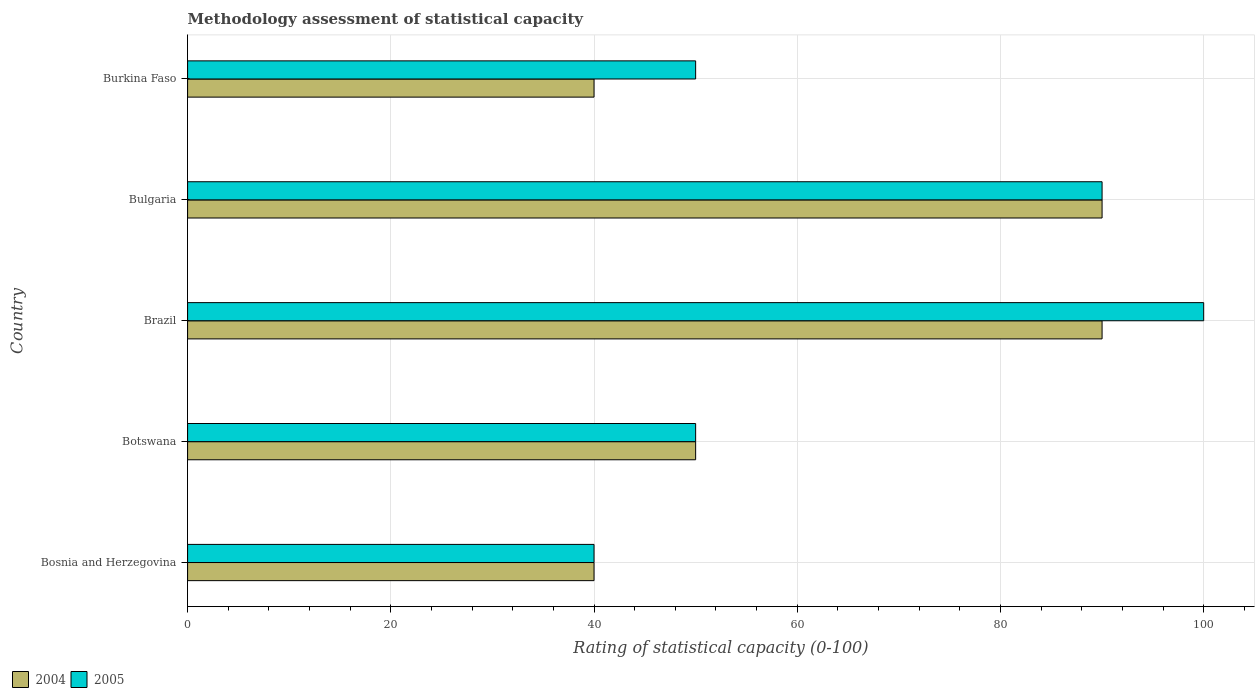How many groups of bars are there?
Offer a terse response. 5. Are the number of bars per tick equal to the number of legend labels?
Provide a succinct answer. Yes. Are the number of bars on each tick of the Y-axis equal?
Ensure brevity in your answer.  Yes. How many bars are there on the 5th tick from the top?
Your answer should be compact. 2. What is the label of the 4th group of bars from the top?
Provide a succinct answer. Botswana. In how many cases, is the number of bars for a given country not equal to the number of legend labels?
Ensure brevity in your answer.  0. Across all countries, what is the minimum rating of statistical capacity in 2005?
Provide a short and direct response. 40. In which country was the rating of statistical capacity in 2005 maximum?
Ensure brevity in your answer.  Brazil. In which country was the rating of statistical capacity in 2005 minimum?
Provide a succinct answer. Bosnia and Herzegovina. What is the total rating of statistical capacity in 2005 in the graph?
Ensure brevity in your answer.  330. What is the difference between the rating of statistical capacity in 2004 in Bosnia and Herzegovina and that in Botswana?
Keep it short and to the point. -10. What is the difference between the rating of statistical capacity in 2005 and rating of statistical capacity in 2004 in Bulgaria?
Offer a very short reply. 0. What is the ratio of the rating of statistical capacity in 2004 in Bulgaria to that in Burkina Faso?
Offer a very short reply. 2.25. Is the rating of statistical capacity in 2005 in Botswana less than that in Brazil?
Provide a succinct answer. Yes. What is the difference between the highest and the second highest rating of statistical capacity in 2004?
Make the answer very short. 0. What is the difference between the highest and the lowest rating of statistical capacity in 2004?
Provide a succinct answer. 50. Is the sum of the rating of statistical capacity in 2004 in Botswana and Bulgaria greater than the maximum rating of statistical capacity in 2005 across all countries?
Provide a short and direct response. Yes. What does the 1st bar from the top in Botswana represents?
Offer a very short reply. 2005. How many bars are there?
Give a very brief answer. 10. Are all the bars in the graph horizontal?
Offer a terse response. Yes. How many countries are there in the graph?
Provide a short and direct response. 5. What is the difference between two consecutive major ticks on the X-axis?
Your response must be concise. 20. Does the graph contain grids?
Give a very brief answer. Yes. Where does the legend appear in the graph?
Ensure brevity in your answer.  Bottom left. How many legend labels are there?
Ensure brevity in your answer.  2. How are the legend labels stacked?
Offer a terse response. Horizontal. What is the title of the graph?
Your answer should be very brief. Methodology assessment of statistical capacity. What is the label or title of the X-axis?
Provide a succinct answer. Rating of statistical capacity (0-100). What is the Rating of statistical capacity (0-100) in 2004 in Bosnia and Herzegovina?
Keep it short and to the point. 40. What is the Rating of statistical capacity (0-100) in 2004 in Bulgaria?
Provide a short and direct response. 90. What is the Rating of statistical capacity (0-100) of 2005 in Bulgaria?
Keep it short and to the point. 90. Across all countries, what is the maximum Rating of statistical capacity (0-100) in 2005?
Ensure brevity in your answer.  100. Across all countries, what is the minimum Rating of statistical capacity (0-100) in 2004?
Your answer should be very brief. 40. What is the total Rating of statistical capacity (0-100) in 2004 in the graph?
Give a very brief answer. 310. What is the total Rating of statistical capacity (0-100) in 2005 in the graph?
Provide a short and direct response. 330. What is the difference between the Rating of statistical capacity (0-100) in 2005 in Bosnia and Herzegovina and that in Brazil?
Provide a short and direct response. -60. What is the difference between the Rating of statistical capacity (0-100) in 2005 in Bosnia and Herzegovina and that in Bulgaria?
Provide a succinct answer. -50. What is the difference between the Rating of statistical capacity (0-100) in 2004 in Bosnia and Herzegovina and that in Burkina Faso?
Keep it short and to the point. 0. What is the difference between the Rating of statistical capacity (0-100) of 2005 in Botswana and that in Burkina Faso?
Your answer should be very brief. 0. What is the difference between the Rating of statistical capacity (0-100) of 2004 in Brazil and that in Bulgaria?
Keep it short and to the point. 0. What is the difference between the Rating of statistical capacity (0-100) of 2005 in Brazil and that in Bulgaria?
Offer a terse response. 10. What is the difference between the Rating of statistical capacity (0-100) of 2005 in Bulgaria and that in Burkina Faso?
Your response must be concise. 40. What is the difference between the Rating of statistical capacity (0-100) of 2004 in Bosnia and Herzegovina and the Rating of statistical capacity (0-100) of 2005 in Botswana?
Your answer should be very brief. -10. What is the difference between the Rating of statistical capacity (0-100) in 2004 in Bosnia and Herzegovina and the Rating of statistical capacity (0-100) in 2005 in Brazil?
Keep it short and to the point. -60. What is the difference between the Rating of statistical capacity (0-100) of 2004 in Bosnia and Herzegovina and the Rating of statistical capacity (0-100) of 2005 in Bulgaria?
Your response must be concise. -50. What is the difference between the Rating of statistical capacity (0-100) in 2004 in Bosnia and Herzegovina and the Rating of statistical capacity (0-100) in 2005 in Burkina Faso?
Provide a succinct answer. -10. What is the difference between the Rating of statistical capacity (0-100) of 2004 in Botswana and the Rating of statistical capacity (0-100) of 2005 in Brazil?
Offer a very short reply. -50. What is the difference between the Rating of statistical capacity (0-100) of 2004 in Botswana and the Rating of statistical capacity (0-100) of 2005 in Bulgaria?
Give a very brief answer. -40. What is the difference between the Rating of statistical capacity (0-100) of 2004 in Botswana and the Rating of statistical capacity (0-100) of 2005 in Burkina Faso?
Ensure brevity in your answer.  0. What is the difference between the Rating of statistical capacity (0-100) in 2004 in Brazil and the Rating of statistical capacity (0-100) in 2005 in Bulgaria?
Provide a succinct answer. 0. What is the difference between the Rating of statistical capacity (0-100) in 2004 in Bulgaria and the Rating of statistical capacity (0-100) in 2005 in Burkina Faso?
Your answer should be compact. 40. What is the average Rating of statistical capacity (0-100) of 2004 per country?
Keep it short and to the point. 62. What is the average Rating of statistical capacity (0-100) of 2005 per country?
Make the answer very short. 66. What is the difference between the Rating of statistical capacity (0-100) of 2004 and Rating of statistical capacity (0-100) of 2005 in Bosnia and Herzegovina?
Offer a terse response. 0. What is the difference between the Rating of statistical capacity (0-100) of 2004 and Rating of statistical capacity (0-100) of 2005 in Botswana?
Provide a succinct answer. 0. What is the ratio of the Rating of statistical capacity (0-100) of 2005 in Bosnia and Herzegovina to that in Botswana?
Offer a very short reply. 0.8. What is the ratio of the Rating of statistical capacity (0-100) of 2004 in Bosnia and Herzegovina to that in Brazil?
Offer a very short reply. 0.44. What is the ratio of the Rating of statistical capacity (0-100) in 2004 in Bosnia and Herzegovina to that in Bulgaria?
Make the answer very short. 0.44. What is the ratio of the Rating of statistical capacity (0-100) of 2005 in Bosnia and Herzegovina to that in Bulgaria?
Your response must be concise. 0.44. What is the ratio of the Rating of statistical capacity (0-100) of 2004 in Bosnia and Herzegovina to that in Burkina Faso?
Provide a short and direct response. 1. What is the ratio of the Rating of statistical capacity (0-100) of 2004 in Botswana to that in Brazil?
Provide a short and direct response. 0.56. What is the ratio of the Rating of statistical capacity (0-100) in 2005 in Botswana to that in Brazil?
Offer a terse response. 0.5. What is the ratio of the Rating of statistical capacity (0-100) in 2004 in Botswana to that in Bulgaria?
Provide a succinct answer. 0.56. What is the ratio of the Rating of statistical capacity (0-100) in 2005 in Botswana to that in Bulgaria?
Ensure brevity in your answer.  0.56. What is the ratio of the Rating of statistical capacity (0-100) in 2004 in Botswana to that in Burkina Faso?
Your answer should be very brief. 1.25. What is the ratio of the Rating of statistical capacity (0-100) in 2004 in Brazil to that in Burkina Faso?
Your answer should be very brief. 2.25. What is the ratio of the Rating of statistical capacity (0-100) in 2004 in Bulgaria to that in Burkina Faso?
Provide a short and direct response. 2.25. What is the difference between the highest and the lowest Rating of statistical capacity (0-100) of 2004?
Make the answer very short. 50. What is the difference between the highest and the lowest Rating of statistical capacity (0-100) of 2005?
Provide a short and direct response. 60. 